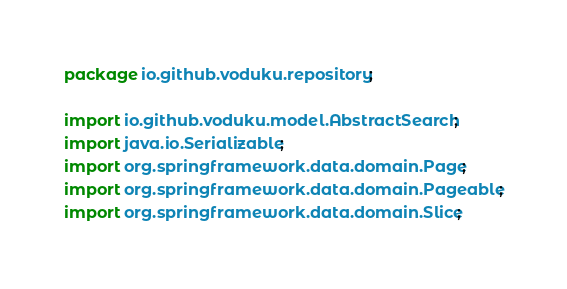Convert code to text. <code><loc_0><loc_0><loc_500><loc_500><_Java_>package io.github.voduku.repository;

import io.github.voduku.model.AbstractSearch;
import java.io.Serializable;
import org.springframework.data.domain.Page;
import org.springframework.data.domain.Pageable;
import org.springframework.data.domain.Slice;</code> 